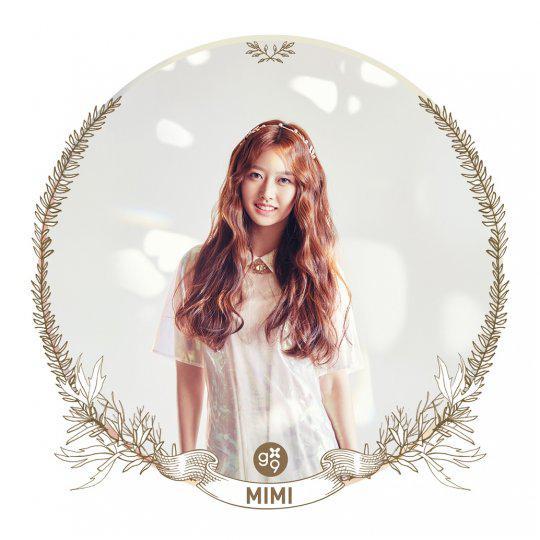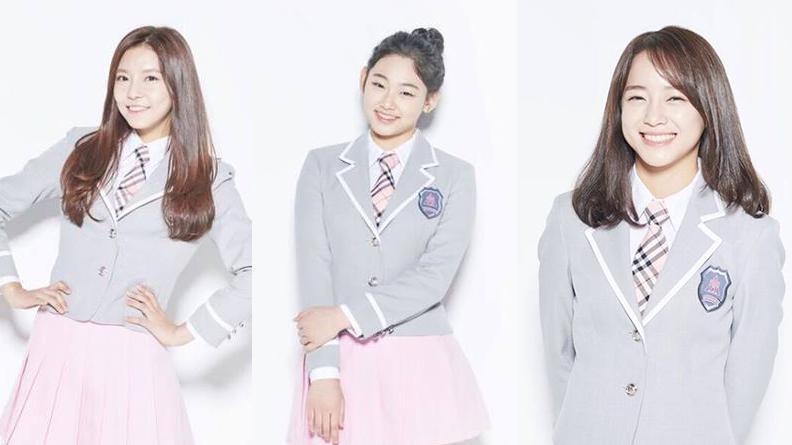The first image is the image on the left, the second image is the image on the right. Evaluate the accuracy of this statement regarding the images: "There are more than four women in total.". Is it true? Answer yes or no. No. 